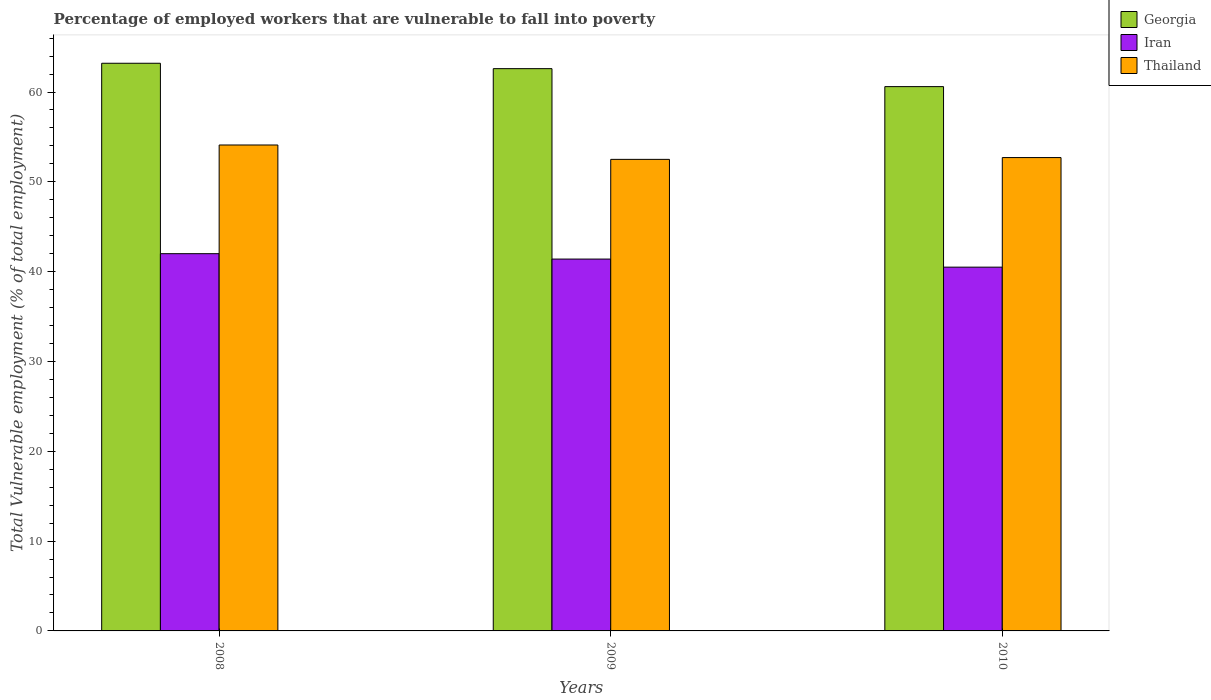How many different coloured bars are there?
Your response must be concise. 3. Are the number of bars per tick equal to the number of legend labels?
Your answer should be compact. Yes. Are the number of bars on each tick of the X-axis equal?
Provide a short and direct response. Yes. What is the label of the 3rd group of bars from the left?
Give a very brief answer. 2010. What is the percentage of employed workers who are vulnerable to fall into poverty in Georgia in 2010?
Provide a short and direct response. 60.6. Across all years, what is the maximum percentage of employed workers who are vulnerable to fall into poverty in Georgia?
Your answer should be compact. 63.2. Across all years, what is the minimum percentage of employed workers who are vulnerable to fall into poverty in Thailand?
Provide a short and direct response. 52.5. In which year was the percentage of employed workers who are vulnerable to fall into poverty in Iran maximum?
Your answer should be very brief. 2008. In which year was the percentage of employed workers who are vulnerable to fall into poverty in Georgia minimum?
Give a very brief answer. 2010. What is the total percentage of employed workers who are vulnerable to fall into poverty in Georgia in the graph?
Ensure brevity in your answer.  186.4. What is the difference between the percentage of employed workers who are vulnerable to fall into poverty in Iran in 2008 and the percentage of employed workers who are vulnerable to fall into poverty in Georgia in 2010?
Make the answer very short. -18.6. What is the average percentage of employed workers who are vulnerable to fall into poverty in Iran per year?
Ensure brevity in your answer.  41.3. In the year 2009, what is the difference between the percentage of employed workers who are vulnerable to fall into poverty in Georgia and percentage of employed workers who are vulnerable to fall into poverty in Iran?
Offer a very short reply. 21.2. What is the ratio of the percentage of employed workers who are vulnerable to fall into poverty in Iran in 2008 to that in 2010?
Give a very brief answer. 1.04. Is the difference between the percentage of employed workers who are vulnerable to fall into poverty in Georgia in 2009 and 2010 greater than the difference between the percentage of employed workers who are vulnerable to fall into poverty in Iran in 2009 and 2010?
Provide a short and direct response. Yes. What is the difference between the highest and the second highest percentage of employed workers who are vulnerable to fall into poverty in Thailand?
Offer a very short reply. 1.4. What is the difference between the highest and the lowest percentage of employed workers who are vulnerable to fall into poverty in Thailand?
Provide a short and direct response. 1.6. What does the 3rd bar from the left in 2010 represents?
Keep it short and to the point. Thailand. What does the 2nd bar from the right in 2010 represents?
Give a very brief answer. Iran. How many years are there in the graph?
Give a very brief answer. 3. How many legend labels are there?
Your response must be concise. 3. How are the legend labels stacked?
Your answer should be very brief. Vertical. What is the title of the graph?
Keep it short and to the point. Percentage of employed workers that are vulnerable to fall into poverty. What is the label or title of the X-axis?
Provide a short and direct response. Years. What is the label or title of the Y-axis?
Keep it short and to the point. Total Vulnerable employment (% of total employment). What is the Total Vulnerable employment (% of total employment) of Georgia in 2008?
Your answer should be very brief. 63.2. What is the Total Vulnerable employment (% of total employment) of Thailand in 2008?
Ensure brevity in your answer.  54.1. What is the Total Vulnerable employment (% of total employment) of Georgia in 2009?
Offer a very short reply. 62.6. What is the Total Vulnerable employment (% of total employment) in Iran in 2009?
Give a very brief answer. 41.4. What is the Total Vulnerable employment (% of total employment) in Thailand in 2009?
Provide a short and direct response. 52.5. What is the Total Vulnerable employment (% of total employment) in Georgia in 2010?
Ensure brevity in your answer.  60.6. What is the Total Vulnerable employment (% of total employment) of Iran in 2010?
Your answer should be compact. 40.5. What is the Total Vulnerable employment (% of total employment) in Thailand in 2010?
Your answer should be very brief. 52.7. Across all years, what is the maximum Total Vulnerable employment (% of total employment) of Georgia?
Offer a terse response. 63.2. Across all years, what is the maximum Total Vulnerable employment (% of total employment) in Iran?
Provide a short and direct response. 42. Across all years, what is the maximum Total Vulnerable employment (% of total employment) in Thailand?
Make the answer very short. 54.1. Across all years, what is the minimum Total Vulnerable employment (% of total employment) of Georgia?
Ensure brevity in your answer.  60.6. Across all years, what is the minimum Total Vulnerable employment (% of total employment) in Iran?
Your answer should be compact. 40.5. Across all years, what is the minimum Total Vulnerable employment (% of total employment) of Thailand?
Your answer should be compact. 52.5. What is the total Total Vulnerable employment (% of total employment) of Georgia in the graph?
Give a very brief answer. 186.4. What is the total Total Vulnerable employment (% of total employment) in Iran in the graph?
Ensure brevity in your answer.  123.9. What is the total Total Vulnerable employment (% of total employment) in Thailand in the graph?
Provide a short and direct response. 159.3. What is the difference between the Total Vulnerable employment (% of total employment) of Thailand in 2008 and that in 2009?
Give a very brief answer. 1.6. What is the difference between the Total Vulnerable employment (% of total employment) of Georgia in 2008 and that in 2010?
Provide a short and direct response. 2.6. What is the difference between the Total Vulnerable employment (% of total employment) of Thailand in 2008 and that in 2010?
Your answer should be compact. 1.4. What is the difference between the Total Vulnerable employment (% of total employment) of Georgia in 2009 and that in 2010?
Make the answer very short. 2. What is the difference between the Total Vulnerable employment (% of total employment) in Georgia in 2008 and the Total Vulnerable employment (% of total employment) in Iran in 2009?
Your answer should be very brief. 21.8. What is the difference between the Total Vulnerable employment (% of total employment) of Georgia in 2008 and the Total Vulnerable employment (% of total employment) of Thailand in 2009?
Provide a short and direct response. 10.7. What is the difference between the Total Vulnerable employment (% of total employment) in Georgia in 2008 and the Total Vulnerable employment (% of total employment) in Iran in 2010?
Offer a terse response. 22.7. What is the difference between the Total Vulnerable employment (% of total employment) in Georgia in 2008 and the Total Vulnerable employment (% of total employment) in Thailand in 2010?
Offer a terse response. 10.5. What is the difference between the Total Vulnerable employment (% of total employment) of Iran in 2008 and the Total Vulnerable employment (% of total employment) of Thailand in 2010?
Your answer should be very brief. -10.7. What is the difference between the Total Vulnerable employment (% of total employment) of Georgia in 2009 and the Total Vulnerable employment (% of total employment) of Iran in 2010?
Provide a short and direct response. 22.1. What is the difference between the Total Vulnerable employment (% of total employment) of Iran in 2009 and the Total Vulnerable employment (% of total employment) of Thailand in 2010?
Your answer should be compact. -11.3. What is the average Total Vulnerable employment (% of total employment) of Georgia per year?
Your answer should be compact. 62.13. What is the average Total Vulnerable employment (% of total employment) of Iran per year?
Ensure brevity in your answer.  41.3. What is the average Total Vulnerable employment (% of total employment) in Thailand per year?
Keep it short and to the point. 53.1. In the year 2008, what is the difference between the Total Vulnerable employment (% of total employment) of Georgia and Total Vulnerable employment (% of total employment) of Iran?
Your answer should be very brief. 21.2. In the year 2008, what is the difference between the Total Vulnerable employment (% of total employment) in Georgia and Total Vulnerable employment (% of total employment) in Thailand?
Your answer should be very brief. 9.1. In the year 2009, what is the difference between the Total Vulnerable employment (% of total employment) in Georgia and Total Vulnerable employment (% of total employment) in Iran?
Make the answer very short. 21.2. In the year 2009, what is the difference between the Total Vulnerable employment (% of total employment) of Georgia and Total Vulnerable employment (% of total employment) of Thailand?
Provide a short and direct response. 10.1. In the year 2010, what is the difference between the Total Vulnerable employment (% of total employment) of Georgia and Total Vulnerable employment (% of total employment) of Iran?
Make the answer very short. 20.1. In the year 2010, what is the difference between the Total Vulnerable employment (% of total employment) of Georgia and Total Vulnerable employment (% of total employment) of Thailand?
Offer a very short reply. 7.9. In the year 2010, what is the difference between the Total Vulnerable employment (% of total employment) in Iran and Total Vulnerable employment (% of total employment) in Thailand?
Keep it short and to the point. -12.2. What is the ratio of the Total Vulnerable employment (% of total employment) of Georgia in 2008 to that in 2009?
Your answer should be compact. 1.01. What is the ratio of the Total Vulnerable employment (% of total employment) in Iran in 2008 to that in 2009?
Provide a succinct answer. 1.01. What is the ratio of the Total Vulnerable employment (% of total employment) of Thailand in 2008 to that in 2009?
Keep it short and to the point. 1.03. What is the ratio of the Total Vulnerable employment (% of total employment) of Georgia in 2008 to that in 2010?
Offer a terse response. 1.04. What is the ratio of the Total Vulnerable employment (% of total employment) of Thailand in 2008 to that in 2010?
Give a very brief answer. 1.03. What is the ratio of the Total Vulnerable employment (% of total employment) in Georgia in 2009 to that in 2010?
Ensure brevity in your answer.  1.03. What is the ratio of the Total Vulnerable employment (% of total employment) in Iran in 2009 to that in 2010?
Keep it short and to the point. 1.02. What is the ratio of the Total Vulnerable employment (% of total employment) of Thailand in 2009 to that in 2010?
Keep it short and to the point. 1. What is the difference between the highest and the second highest Total Vulnerable employment (% of total employment) in Georgia?
Give a very brief answer. 0.6. What is the difference between the highest and the lowest Total Vulnerable employment (% of total employment) in Georgia?
Give a very brief answer. 2.6. 